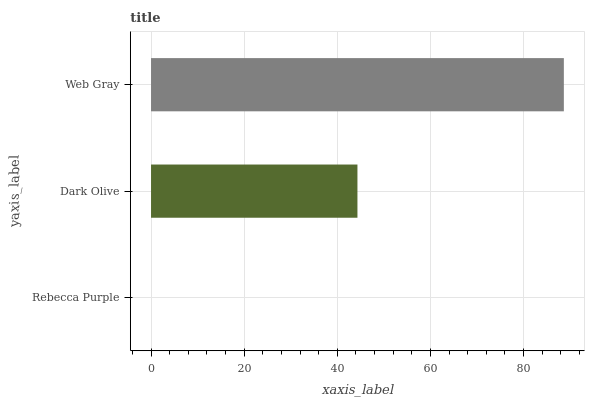Is Rebecca Purple the minimum?
Answer yes or no. Yes. Is Web Gray the maximum?
Answer yes or no. Yes. Is Dark Olive the minimum?
Answer yes or no. No. Is Dark Olive the maximum?
Answer yes or no. No. Is Dark Olive greater than Rebecca Purple?
Answer yes or no. Yes. Is Rebecca Purple less than Dark Olive?
Answer yes or no. Yes. Is Rebecca Purple greater than Dark Olive?
Answer yes or no. No. Is Dark Olive less than Rebecca Purple?
Answer yes or no. No. Is Dark Olive the high median?
Answer yes or no. Yes. Is Dark Olive the low median?
Answer yes or no. Yes. Is Web Gray the high median?
Answer yes or no. No. Is Rebecca Purple the low median?
Answer yes or no. No. 